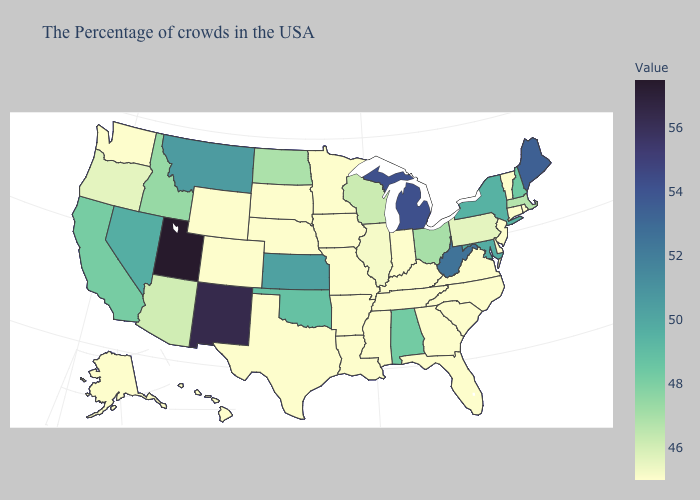Which states have the highest value in the USA?
Keep it brief. Utah. Does Maryland have the lowest value in the South?
Concise answer only. No. Among the states that border Montana , does Idaho have the lowest value?
Give a very brief answer. No. Does Alaska have the lowest value in the West?
Short answer required. Yes. Among the states that border New York , does Massachusetts have the lowest value?
Quick response, please. No. Does Utah have the highest value in the West?
Give a very brief answer. Yes. 